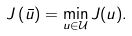<formula> <loc_0><loc_0><loc_500><loc_500>J \left ( \bar { u } \right ) = \min _ { u \in \mathcal { U } } J ( u ) .</formula> 